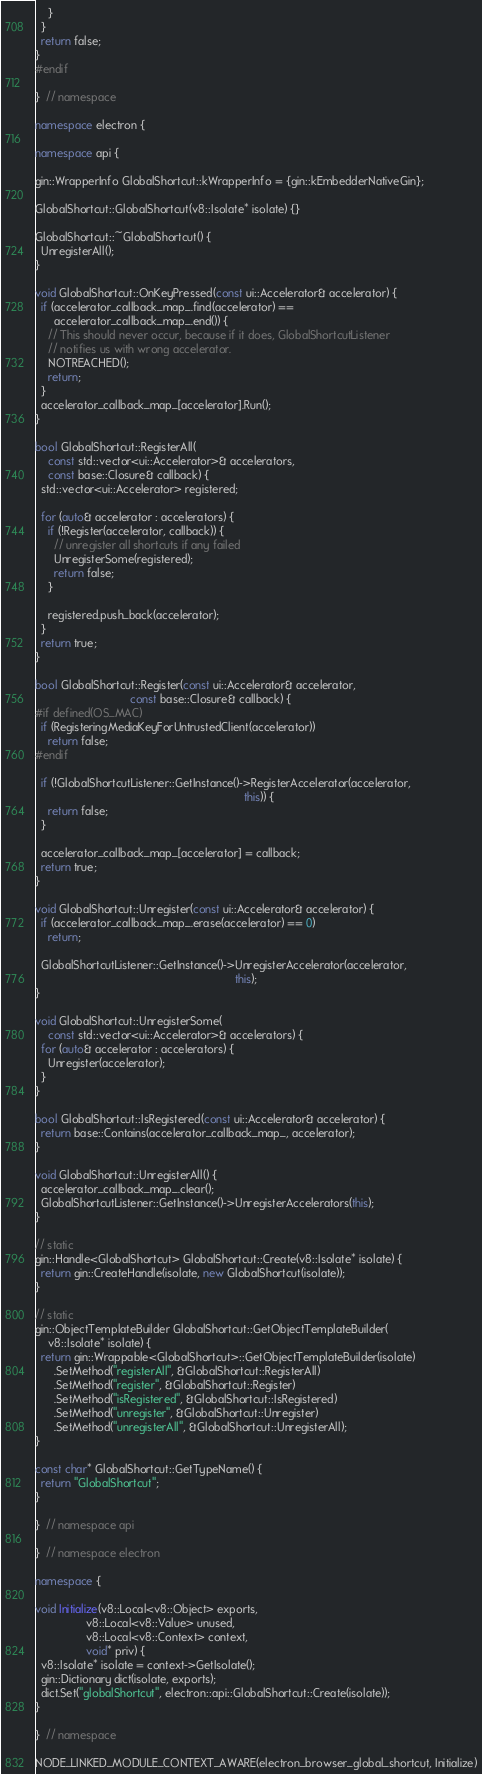<code> <loc_0><loc_0><loc_500><loc_500><_C++_>    }
  }
  return false;
}
#endif

}  // namespace

namespace electron {

namespace api {

gin::WrapperInfo GlobalShortcut::kWrapperInfo = {gin::kEmbedderNativeGin};

GlobalShortcut::GlobalShortcut(v8::Isolate* isolate) {}

GlobalShortcut::~GlobalShortcut() {
  UnregisterAll();
}

void GlobalShortcut::OnKeyPressed(const ui::Accelerator& accelerator) {
  if (accelerator_callback_map_.find(accelerator) ==
      accelerator_callback_map_.end()) {
    // This should never occur, because if it does, GlobalShortcutListener
    // notifies us with wrong accelerator.
    NOTREACHED();
    return;
  }
  accelerator_callback_map_[accelerator].Run();
}

bool GlobalShortcut::RegisterAll(
    const std::vector<ui::Accelerator>& accelerators,
    const base::Closure& callback) {
  std::vector<ui::Accelerator> registered;

  for (auto& accelerator : accelerators) {
    if (!Register(accelerator, callback)) {
      // unregister all shortcuts if any failed
      UnregisterSome(registered);
      return false;
    }

    registered.push_back(accelerator);
  }
  return true;
}

bool GlobalShortcut::Register(const ui::Accelerator& accelerator,
                              const base::Closure& callback) {
#if defined(OS_MAC)
  if (RegisteringMediaKeyForUntrustedClient(accelerator))
    return false;
#endif

  if (!GlobalShortcutListener::GetInstance()->RegisterAccelerator(accelerator,
                                                                  this)) {
    return false;
  }

  accelerator_callback_map_[accelerator] = callback;
  return true;
}

void GlobalShortcut::Unregister(const ui::Accelerator& accelerator) {
  if (accelerator_callback_map_.erase(accelerator) == 0)
    return;

  GlobalShortcutListener::GetInstance()->UnregisterAccelerator(accelerator,
                                                               this);
}

void GlobalShortcut::UnregisterSome(
    const std::vector<ui::Accelerator>& accelerators) {
  for (auto& accelerator : accelerators) {
    Unregister(accelerator);
  }
}

bool GlobalShortcut::IsRegistered(const ui::Accelerator& accelerator) {
  return base::Contains(accelerator_callback_map_, accelerator);
}

void GlobalShortcut::UnregisterAll() {
  accelerator_callback_map_.clear();
  GlobalShortcutListener::GetInstance()->UnregisterAccelerators(this);
}

// static
gin::Handle<GlobalShortcut> GlobalShortcut::Create(v8::Isolate* isolate) {
  return gin::CreateHandle(isolate, new GlobalShortcut(isolate));
}

// static
gin::ObjectTemplateBuilder GlobalShortcut::GetObjectTemplateBuilder(
    v8::Isolate* isolate) {
  return gin::Wrappable<GlobalShortcut>::GetObjectTemplateBuilder(isolate)
      .SetMethod("registerAll", &GlobalShortcut::RegisterAll)
      .SetMethod("register", &GlobalShortcut::Register)
      .SetMethod("isRegistered", &GlobalShortcut::IsRegistered)
      .SetMethod("unregister", &GlobalShortcut::Unregister)
      .SetMethod("unregisterAll", &GlobalShortcut::UnregisterAll);
}

const char* GlobalShortcut::GetTypeName() {
  return "GlobalShortcut";
}

}  // namespace api

}  // namespace electron

namespace {

void Initialize(v8::Local<v8::Object> exports,
                v8::Local<v8::Value> unused,
                v8::Local<v8::Context> context,
                void* priv) {
  v8::Isolate* isolate = context->GetIsolate();
  gin::Dictionary dict(isolate, exports);
  dict.Set("globalShortcut", electron::api::GlobalShortcut::Create(isolate));
}

}  // namespace

NODE_LINKED_MODULE_CONTEXT_AWARE(electron_browser_global_shortcut, Initialize)
</code> 